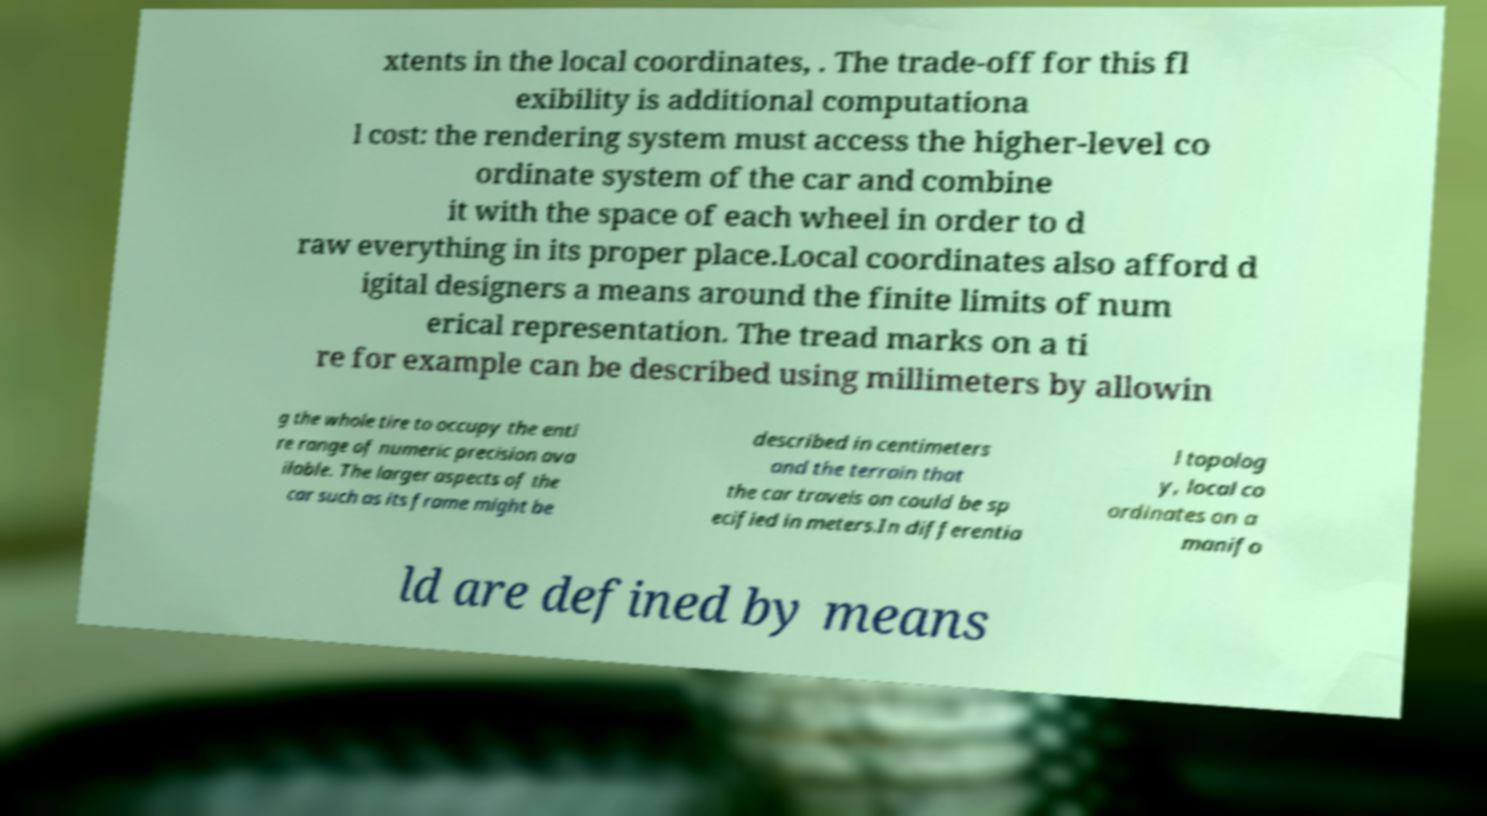Could you extract and type out the text from this image? xtents in the local coordinates, . The trade-off for this fl exibility is additional computationa l cost: the rendering system must access the higher-level co ordinate system of the car and combine it with the space of each wheel in order to d raw everything in its proper place.Local coordinates also afford d igital designers a means around the finite limits of num erical representation. The tread marks on a ti re for example can be described using millimeters by allowin g the whole tire to occupy the enti re range of numeric precision ava ilable. The larger aspects of the car such as its frame might be described in centimeters and the terrain that the car travels on could be sp ecified in meters.In differentia l topolog y, local co ordinates on a manifo ld are defined by means 